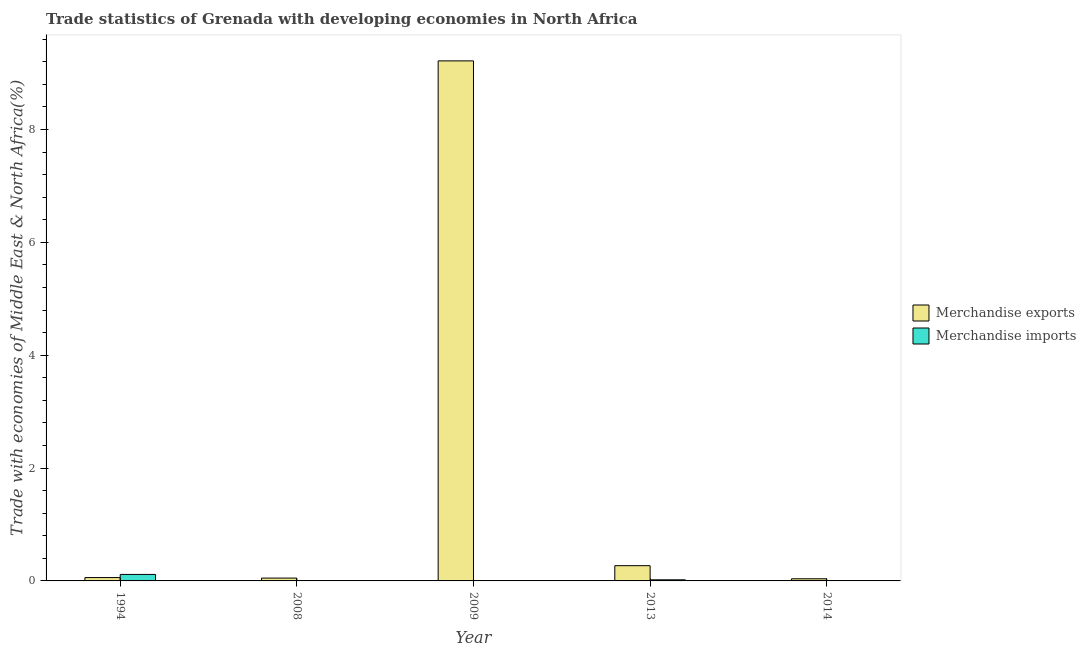Are the number of bars per tick equal to the number of legend labels?
Give a very brief answer. Yes. How many bars are there on the 2nd tick from the left?
Your answer should be compact. 2. In how many cases, is the number of bars for a given year not equal to the number of legend labels?
Keep it short and to the point. 0. What is the merchandise exports in 2008?
Provide a short and direct response. 0.05. Across all years, what is the maximum merchandise exports?
Ensure brevity in your answer.  9.22. Across all years, what is the minimum merchandise exports?
Provide a succinct answer. 0.04. In which year was the merchandise imports maximum?
Your response must be concise. 1994. What is the total merchandise exports in the graph?
Keep it short and to the point. 9.63. What is the difference between the merchandise exports in 2008 and that in 2013?
Offer a terse response. -0.22. What is the difference between the merchandise exports in 2008 and the merchandise imports in 2009?
Make the answer very short. -9.17. What is the average merchandise imports per year?
Provide a succinct answer. 0.03. In the year 1994, what is the difference between the merchandise imports and merchandise exports?
Keep it short and to the point. 0. What is the ratio of the merchandise exports in 1994 to that in 2013?
Offer a terse response. 0.22. What is the difference between the highest and the second highest merchandise exports?
Make the answer very short. 8.95. What is the difference between the highest and the lowest merchandise imports?
Offer a very short reply. 0.11. In how many years, is the merchandise imports greater than the average merchandise imports taken over all years?
Offer a terse response. 1. Is the sum of the merchandise imports in 2009 and 2014 greater than the maximum merchandise exports across all years?
Offer a terse response. No. Are all the bars in the graph horizontal?
Give a very brief answer. No. Are the values on the major ticks of Y-axis written in scientific E-notation?
Your response must be concise. No. Does the graph contain grids?
Provide a succinct answer. No. How many legend labels are there?
Your answer should be very brief. 2. How are the legend labels stacked?
Offer a very short reply. Vertical. What is the title of the graph?
Keep it short and to the point. Trade statistics of Grenada with developing economies in North Africa. What is the label or title of the X-axis?
Your answer should be very brief. Year. What is the label or title of the Y-axis?
Ensure brevity in your answer.  Trade with economies of Middle East & North Africa(%). What is the Trade with economies of Middle East & North Africa(%) in Merchandise exports in 1994?
Make the answer very short. 0.06. What is the Trade with economies of Middle East & North Africa(%) in Merchandise imports in 1994?
Your answer should be very brief. 0.11. What is the Trade with economies of Middle East & North Africa(%) of Merchandise exports in 2008?
Give a very brief answer. 0.05. What is the Trade with economies of Middle East & North Africa(%) of Merchandise imports in 2008?
Make the answer very short. 0. What is the Trade with economies of Middle East & North Africa(%) of Merchandise exports in 2009?
Your answer should be compact. 9.22. What is the Trade with economies of Middle East & North Africa(%) in Merchandise imports in 2009?
Offer a very short reply. 0. What is the Trade with economies of Middle East & North Africa(%) in Merchandise exports in 2013?
Keep it short and to the point. 0.27. What is the Trade with economies of Middle East & North Africa(%) in Merchandise imports in 2013?
Offer a terse response. 0.02. What is the Trade with economies of Middle East & North Africa(%) in Merchandise exports in 2014?
Provide a short and direct response. 0.04. What is the Trade with economies of Middle East & North Africa(%) of Merchandise imports in 2014?
Offer a very short reply. 0. Across all years, what is the maximum Trade with economies of Middle East & North Africa(%) of Merchandise exports?
Provide a succinct answer. 9.22. Across all years, what is the maximum Trade with economies of Middle East & North Africa(%) of Merchandise imports?
Keep it short and to the point. 0.11. Across all years, what is the minimum Trade with economies of Middle East & North Africa(%) of Merchandise exports?
Ensure brevity in your answer.  0.04. Across all years, what is the minimum Trade with economies of Middle East & North Africa(%) in Merchandise imports?
Ensure brevity in your answer.  0. What is the total Trade with economies of Middle East & North Africa(%) of Merchandise exports in the graph?
Offer a very short reply. 9.63. What is the total Trade with economies of Middle East & North Africa(%) in Merchandise imports in the graph?
Your answer should be very brief. 0.14. What is the difference between the Trade with economies of Middle East & North Africa(%) of Merchandise exports in 1994 and that in 2008?
Provide a succinct answer. 0.01. What is the difference between the Trade with economies of Middle East & North Africa(%) of Merchandise imports in 1994 and that in 2008?
Give a very brief answer. 0.11. What is the difference between the Trade with economies of Middle East & North Africa(%) of Merchandise exports in 1994 and that in 2009?
Keep it short and to the point. -9.16. What is the difference between the Trade with economies of Middle East & North Africa(%) in Merchandise exports in 1994 and that in 2013?
Your answer should be very brief. -0.21. What is the difference between the Trade with economies of Middle East & North Africa(%) in Merchandise imports in 1994 and that in 2013?
Provide a succinct answer. 0.1. What is the difference between the Trade with economies of Middle East & North Africa(%) in Merchandise exports in 1994 and that in 2014?
Your answer should be very brief. 0.02. What is the difference between the Trade with economies of Middle East & North Africa(%) of Merchandise imports in 1994 and that in 2014?
Your response must be concise. 0.11. What is the difference between the Trade with economies of Middle East & North Africa(%) in Merchandise exports in 2008 and that in 2009?
Offer a terse response. -9.17. What is the difference between the Trade with economies of Middle East & North Africa(%) in Merchandise imports in 2008 and that in 2009?
Provide a succinct answer. -0. What is the difference between the Trade with economies of Middle East & North Africa(%) in Merchandise exports in 2008 and that in 2013?
Make the answer very short. -0.22. What is the difference between the Trade with economies of Middle East & North Africa(%) in Merchandise imports in 2008 and that in 2013?
Offer a very short reply. -0.02. What is the difference between the Trade with economies of Middle East & North Africa(%) of Merchandise exports in 2008 and that in 2014?
Your answer should be compact. 0.01. What is the difference between the Trade with economies of Middle East & North Africa(%) of Merchandise imports in 2008 and that in 2014?
Offer a very short reply. -0. What is the difference between the Trade with economies of Middle East & North Africa(%) in Merchandise exports in 2009 and that in 2013?
Offer a terse response. 8.95. What is the difference between the Trade with economies of Middle East & North Africa(%) in Merchandise imports in 2009 and that in 2013?
Your answer should be very brief. -0.02. What is the difference between the Trade with economies of Middle East & North Africa(%) of Merchandise exports in 2009 and that in 2014?
Your response must be concise. 9.18. What is the difference between the Trade with economies of Middle East & North Africa(%) of Merchandise imports in 2009 and that in 2014?
Provide a succinct answer. 0. What is the difference between the Trade with economies of Middle East & North Africa(%) in Merchandise exports in 2013 and that in 2014?
Keep it short and to the point. 0.23. What is the difference between the Trade with economies of Middle East & North Africa(%) in Merchandise imports in 2013 and that in 2014?
Provide a short and direct response. 0.02. What is the difference between the Trade with economies of Middle East & North Africa(%) in Merchandise exports in 1994 and the Trade with economies of Middle East & North Africa(%) in Merchandise imports in 2008?
Make the answer very short. 0.06. What is the difference between the Trade with economies of Middle East & North Africa(%) in Merchandise exports in 1994 and the Trade with economies of Middle East & North Africa(%) in Merchandise imports in 2009?
Your answer should be compact. 0.06. What is the difference between the Trade with economies of Middle East & North Africa(%) in Merchandise exports in 1994 and the Trade with economies of Middle East & North Africa(%) in Merchandise imports in 2014?
Keep it short and to the point. 0.06. What is the difference between the Trade with economies of Middle East & North Africa(%) in Merchandise exports in 2008 and the Trade with economies of Middle East & North Africa(%) in Merchandise imports in 2009?
Your answer should be very brief. 0.05. What is the difference between the Trade with economies of Middle East & North Africa(%) in Merchandise exports in 2008 and the Trade with economies of Middle East & North Africa(%) in Merchandise imports in 2013?
Keep it short and to the point. 0.03. What is the difference between the Trade with economies of Middle East & North Africa(%) of Merchandise exports in 2008 and the Trade with economies of Middle East & North Africa(%) of Merchandise imports in 2014?
Offer a terse response. 0.05. What is the difference between the Trade with economies of Middle East & North Africa(%) in Merchandise exports in 2009 and the Trade with economies of Middle East & North Africa(%) in Merchandise imports in 2013?
Offer a terse response. 9.2. What is the difference between the Trade with economies of Middle East & North Africa(%) in Merchandise exports in 2009 and the Trade with economies of Middle East & North Africa(%) in Merchandise imports in 2014?
Make the answer very short. 9.21. What is the difference between the Trade with economies of Middle East & North Africa(%) in Merchandise exports in 2013 and the Trade with economies of Middle East & North Africa(%) in Merchandise imports in 2014?
Provide a short and direct response. 0.27. What is the average Trade with economies of Middle East & North Africa(%) in Merchandise exports per year?
Offer a very short reply. 1.93. What is the average Trade with economies of Middle East & North Africa(%) of Merchandise imports per year?
Ensure brevity in your answer.  0.03. In the year 1994, what is the difference between the Trade with economies of Middle East & North Africa(%) of Merchandise exports and Trade with economies of Middle East & North Africa(%) of Merchandise imports?
Offer a very short reply. -0.06. In the year 2008, what is the difference between the Trade with economies of Middle East & North Africa(%) of Merchandise exports and Trade with economies of Middle East & North Africa(%) of Merchandise imports?
Provide a succinct answer. 0.05. In the year 2009, what is the difference between the Trade with economies of Middle East & North Africa(%) of Merchandise exports and Trade with economies of Middle East & North Africa(%) of Merchandise imports?
Your answer should be compact. 9.21. In the year 2013, what is the difference between the Trade with economies of Middle East & North Africa(%) in Merchandise exports and Trade with economies of Middle East & North Africa(%) in Merchandise imports?
Your answer should be very brief. 0.25. In the year 2014, what is the difference between the Trade with economies of Middle East & North Africa(%) in Merchandise exports and Trade with economies of Middle East & North Africa(%) in Merchandise imports?
Make the answer very short. 0.03. What is the ratio of the Trade with economies of Middle East & North Africa(%) of Merchandise exports in 1994 to that in 2008?
Provide a short and direct response. 1.18. What is the ratio of the Trade with economies of Middle East & North Africa(%) in Merchandise imports in 1994 to that in 2008?
Ensure brevity in your answer.  259.97. What is the ratio of the Trade with economies of Middle East & North Africa(%) of Merchandise exports in 1994 to that in 2009?
Provide a succinct answer. 0.01. What is the ratio of the Trade with economies of Middle East & North Africa(%) in Merchandise imports in 1994 to that in 2009?
Ensure brevity in your answer.  30.38. What is the ratio of the Trade with economies of Middle East & North Africa(%) of Merchandise exports in 1994 to that in 2013?
Keep it short and to the point. 0.22. What is the ratio of the Trade with economies of Middle East & North Africa(%) in Merchandise imports in 1994 to that in 2013?
Ensure brevity in your answer.  5.91. What is the ratio of the Trade with economies of Middle East & North Africa(%) of Merchandise exports in 1994 to that in 2014?
Offer a terse response. 1.57. What is the ratio of the Trade with economies of Middle East & North Africa(%) in Merchandise imports in 1994 to that in 2014?
Your answer should be compact. 31.57. What is the ratio of the Trade with economies of Middle East & North Africa(%) in Merchandise exports in 2008 to that in 2009?
Your answer should be very brief. 0.01. What is the ratio of the Trade with economies of Middle East & North Africa(%) of Merchandise imports in 2008 to that in 2009?
Offer a terse response. 0.12. What is the ratio of the Trade with economies of Middle East & North Africa(%) in Merchandise exports in 2008 to that in 2013?
Offer a terse response. 0.19. What is the ratio of the Trade with economies of Middle East & North Africa(%) in Merchandise imports in 2008 to that in 2013?
Your answer should be very brief. 0.02. What is the ratio of the Trade with economies of Middle East & North Africa(%) in Merchandise exports in 2008 to that in 2014?
Your answer should be very brief. 1.33. What is the ratio of the Trade with economies of Middle East & North Africa(%) in Merchandise imports in 2008 to that in 2014?
Offer a very short reply. 0.12. What is the ratio of the Trade with economies of Middle East & North Africa(%) of Merchandise exports in 2009 to that in 2013?
Offer a terse response. 34.11. What is the ratio of the Trade with economies of Middle East & North Africa(%) in Merchandise imports in 2009 to that in 2013?
Your answer should be compact. 0.19. What is the ratio of the Trade with economies of Middle East & North Africa(%) of Merchandise exports in 2009 to that in 2014?
Provide a short and direct response. 243.92. What is the ratio of the Trade with economies of Middle East & North Africa(%) in Merchandise imports in 2009 to that in 2014?
Your answer should be compact. 1.04. What is the ratio of the Trade with economies of Middle East & North Africa(%) in Merchandise exports in 2013 to that in 2014?
Make the answer very short. 7.15. What is the ratio of the Trade with economies of Middle East & North Africa(%) of Merchandise imports in 2013 to that in 2014?
Offer a terse response. 5.34. What is the difference between the highest and the second highest Trade with economies of Middle East & North Africa(%) of Merchandise exports?
Offer a terse response. 8.95. What is the difference between the highest and the second highest Trade with economies of Middle East & North Africa(%) in Merchandise imports?
Ensure brevity in your answer.  0.1. What is the difference between the highest and the lowest Trade with economies of Middle East & North Africa(%) of Merchandise exports?
Give a very brief answer. 9.18. What is the difference between the highest and the lowest Trade with economies of Middle East & North Africa(%) of Merchandise imports?
Ensure brevity in your answer.  0.11. 